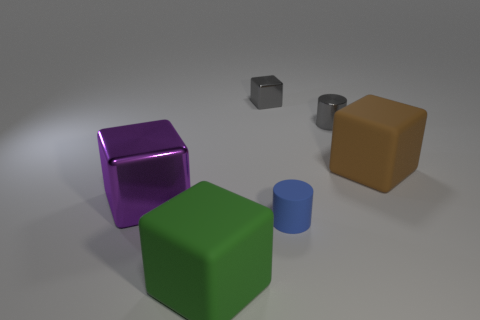What number of large metal things have the same color as the small metal block?
Keep it short and to the point. 0. Do the green thing and the big brown block that is behind the big purple block have the same material?
Provide a short and direct response. Yes. Is the number of large metal blocks to the left of the blue rubber cylinder greater than the number of small cyan shiny spheres?
Make the answer very short. Yes. There is a rubber cylinder; is it the same color as the shiny cube that is in front of the brown rubber thing?
Make the answer very short. No. Are there the same number of tiny metal things that are in front of the gray metallic cube and tiny blue matte things behind the tiny matte cylinder?
Your answer should be compact. No. There is a big cube that is in front of the small blue cylinder; what is it made of?
Offer a very short reply. Rubber. What number of objects are either matte blocks on the right side of the big green rubber block or green balls?
Your answer should be compact. 1. How many other things are the same shape as the big green matte thing?
Your response must be concise. 3. There is a matte thing to the left of the tiny cube; does it have the same shape as the big brown object?
Your answer should be compact. Yes. There is a blue rubber cylinder; are there any rubber objects to the left of it?
Offer a terse response. Yes. 